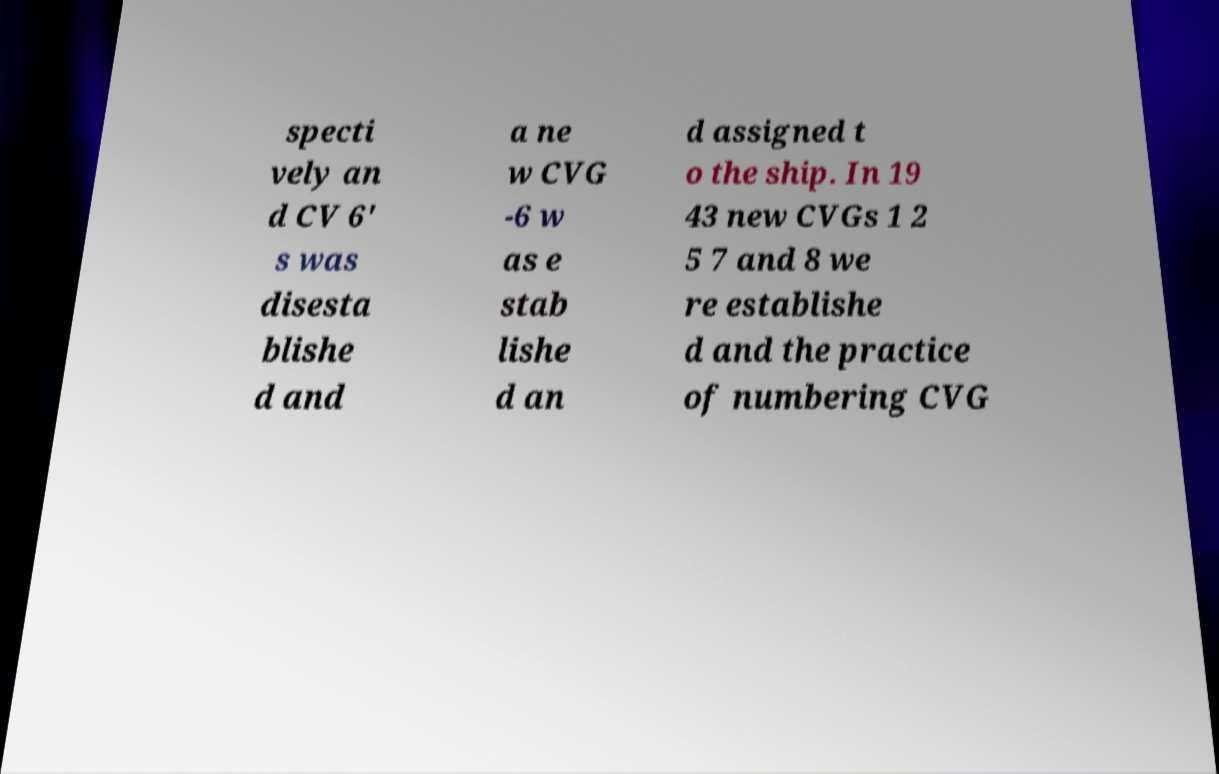What messages or text are displayed in this image? I need them in a readable, typed format. specti vely an d CV 6' s was disesta blishe d and a ne w CVG -6 w as e stab lishe d an d assigned t o the ship. In 19 43 new CVGs 1 2 5 7 and 8 we re establishe d and the practice of numbering CVG 